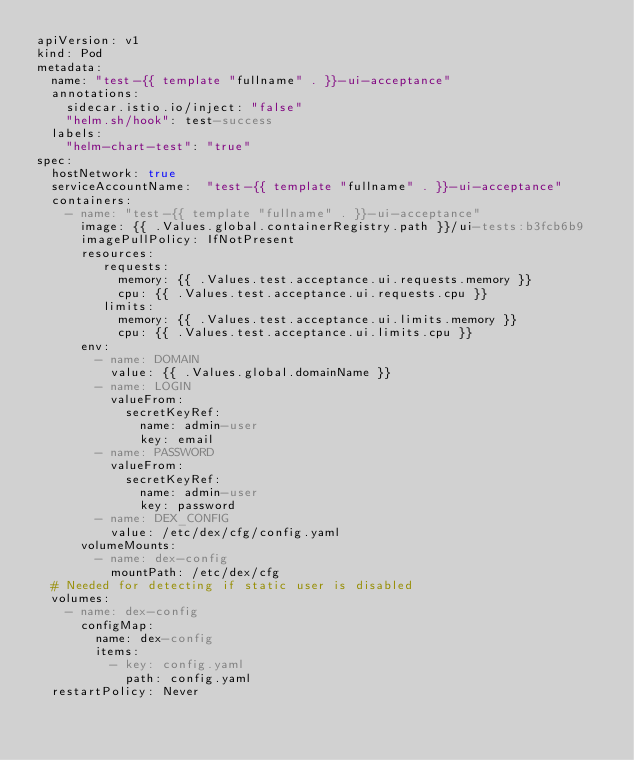Convert code to text. <code><loc_0><loc_0><loc_500><loc_500><_YAML_>apiVersion: v1
kind: Pod
metadata:
  name: "test-{{ template "fullname" . }}-ui-acceptance"
  annotations:
    sidecar.istio.io/inject: "false"
    "helm.sh/hook": test-success
  labels:
    "helm-chart-test": "true"
spec:
  hostNetwork: true
  serviceAccountName:  "test-{{ template "fullname" . }}-ui-acceptance"
  containers:
    - name: "test-{{ template "fullname" . }}-ui-acceptance"
      image: {{ .Values.global.containerRegistry.path }}/ui-tests:b3fcb6b9
      imagePullPolicy: IfNotPresent
      resources:
         requests:
           memory: {{ .Values.test.acceptance.ui.requests.memory }}
           cpu: {{ .Values.test.acceptance.ui.requests.cpu }}
         limits:
           memory: {{ .Values.test.acceptance.ui.limits.memory }}
           cpu: {{ .Values.test.acceptance.ui.limits.cpu }}
      env:
        - name: DOMAIN
          value: {{ .Values.global.domainName }}
        - name: LOGIN
          valueFrom:
            secretKeyRef:
              name: admin-user
              key: email
        - name: PASSWORD
          valueFrom:
            secretKeyRef:
              name: admin-user
              key: password
        - name: DEX_CONFIG
          value: /etc/dex/cfg/config.yaml
      volumeMounts:
        - name: dex-config
          mountPath: /etc/dex/cfg
  # Needed for detecting if static user is disabled
  volumes:
    - name: dex-config
      configMap:
        name: dex-config
        items:
          - key: config.yaml
            path: config.yaml
  restartPolicy: Never
</code> 